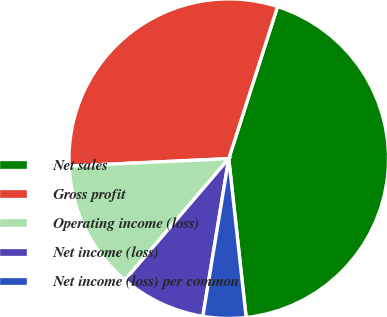Convert chart. <chart><loc_0><loc_0><loc_500><loc_500><pie_chart><fcel>Net sales<fcel>Gross profit<fcel>Operating income (loss)<fcel>Net income (loss)<fcel>Net income (loss) per common<nl><fcel>43.32%<fcel>30.68%<fcel>13.0%<fcel>8.67%<fcel>4.33%<nl></chart> 